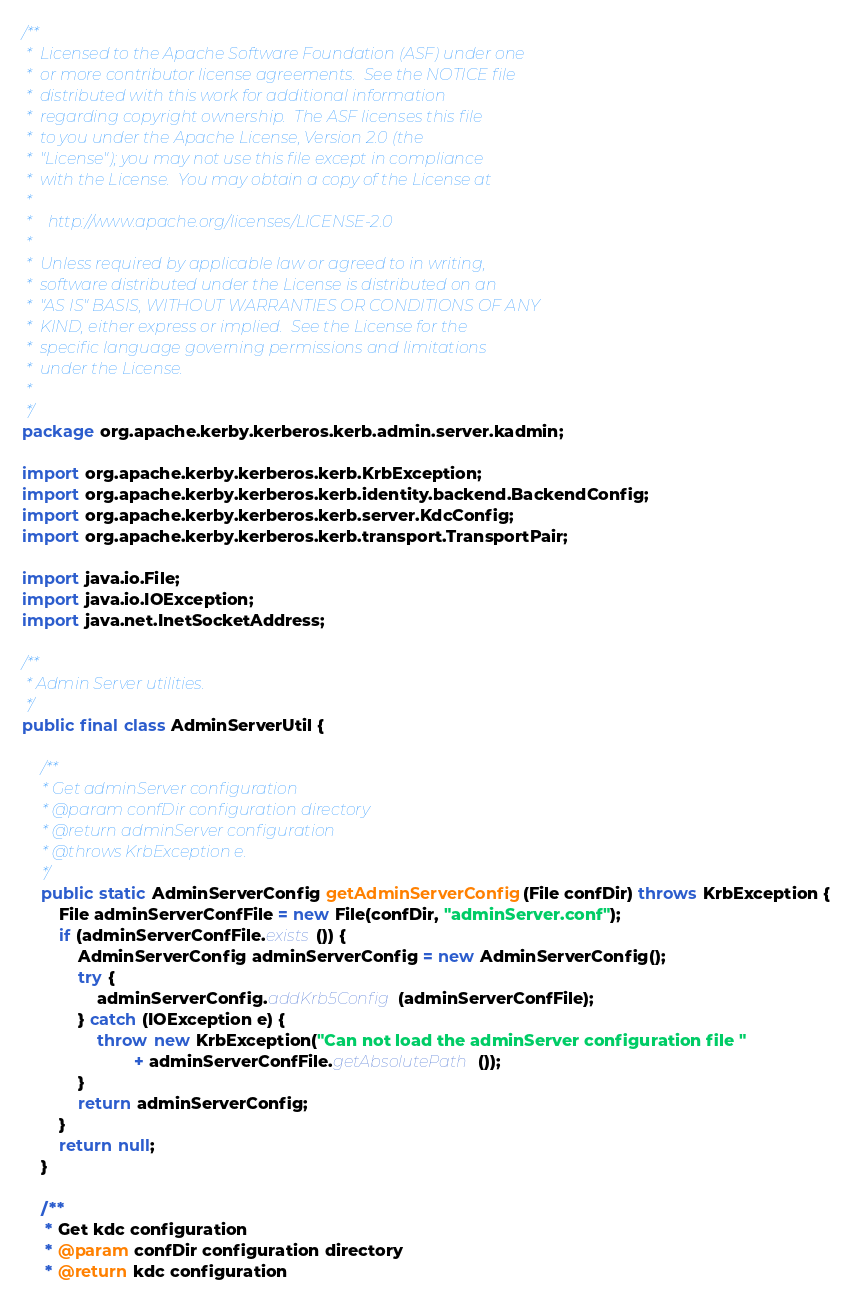Convert code to text. <code><loc_0><loc_0><loc_500><loc_500><_Java_>/**
 *  Licensed to the Apache Software Foundation (ASF) under one
 *  or more contributor license agreements.  See the NOTICE file
 *  distributed with this work for additional information
 *  regarding copyright ownership.  The ASF licenses this file
 *  to you under the Apache License, Version 2.0 (the
 *  "License"); you may not use this file except in compliance
 *  with the License.  You may obtain a copy of the License at
 *
 *    http://www.apache.org/licenses/LICENSE-2.0
 *
 *  Unless required by applicable law or agreed to in writing,
 *  software distributed under the License is distributed on an
 *  "AS IS" BASIS, WITHOUT WARRANTIES OR CONDITIONS OF ANY
 *  KIND, either express or implied.  See the License for the
 *  specific language governing permissions and limitations
 *  under the License.
 *
 */
package org.apache.kerby.kerberos.kerb.admin.server.kadmin;

import org.apache.kerby.kerberos.kerb.KrbException;
import org.apache.kerby.kerberos.kerb.identity.backend.BackendConfig;
import org.apache.kerby.kerberos.kerb.server.KdcConfig;
import org.apache.kerby.kerberos.kerb.transport.TransportPair;

import java.io.File;
import java.io.IOException;
import java.net.InetSocketAddress;

/**
 * Admin Server utilities.
 */
public final class AdminServerUtil {

    /**
     * Get adminServer configuration
     * @param confDir configuration directory
     * @return adminServer configuration
     * @throws KrbException e.
     */
    public static AdminServerConfig getAdminServerConfig(File confDir) throws KrbException {
        File adminServerConfFile = new File(confDir, "adminServer.conf");
        if (adminServerConfFile.exists()) {
            AdminServerConfig adminServerConfig = new AdminServerConfig();
            try {
                adminServerConfig.addKrb5Config(adminServerConfFile);
            } catch (IOException e) {
                throw new KrbException("Can not load the adminServer configuration file "
                        + adminServerConfFile.getAbsolutePath());
            }
            return adminServerConfig;
        }
        return null;
    }

    /**
     * Get kdc configuration
     * @param confDir configuration directory
     * @return kdc configuration</code> 